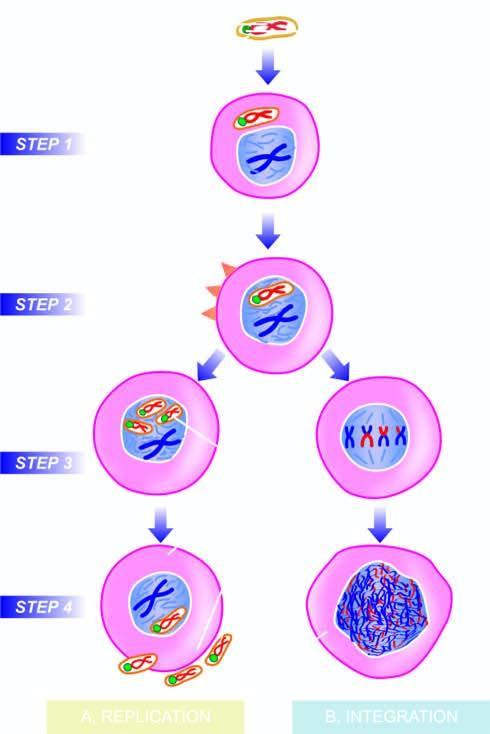what is viral dna incorporated into?
Answer the question using a single word or phrase. The host nucleus 